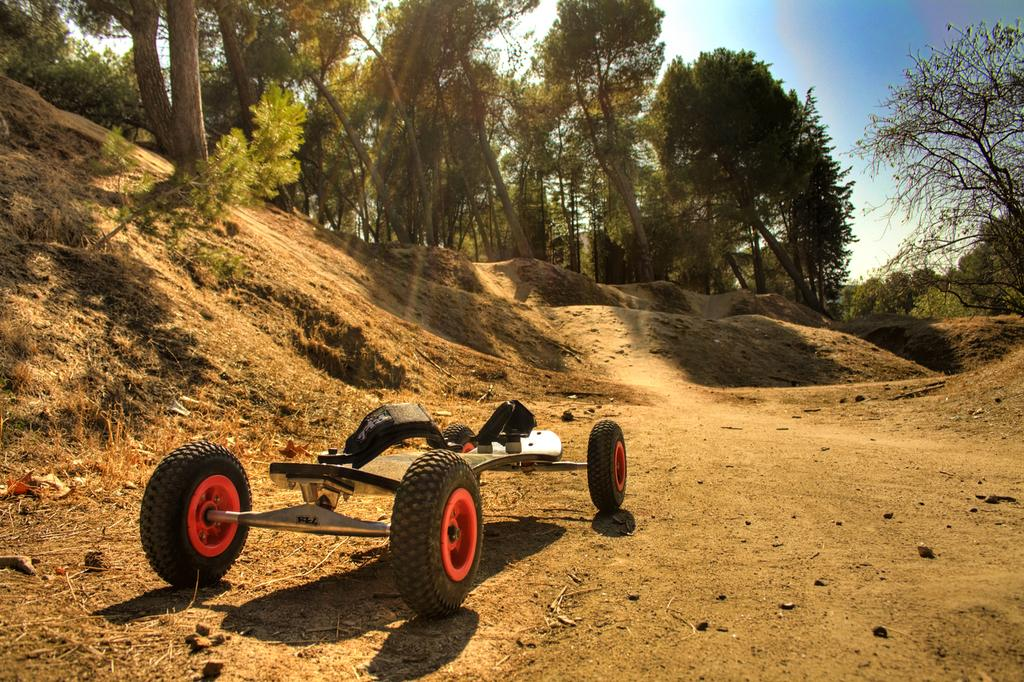What is the main subject in the foreground of the image? There is a vehicle in the foreground of the image. What type of terrain surrounds the vehicle? The ground around the vehicle is covered with sand. What can be seen in the background of the image? There are trees visible in the background of the image. Where is the drawer located in the image? There is no drawer present in the image. Can you describe the lamp in the image? There is no lamp present in the image. 